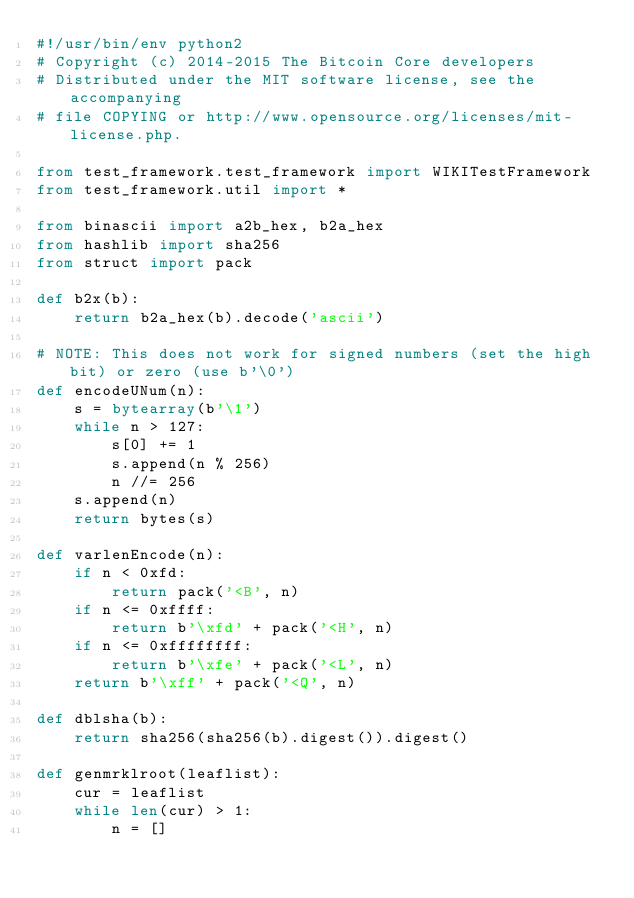<code> <loc_0><loc_0><loc_500><loc_500><_Python_>#!/usr/bin/env python2
# Copyright (c) 2014-2015 The Bitcoin Core developers
# Distributed under the MIT software license, see the accompanying
# file COPYING or http://www.opensource.org/licenses/mit-license.php.

from test_framework.test_framework import WIKITestFramework
from test_framework.util import *

from binascii import a2b_hex, b2a_hex
from hashlib import sha256
from struct import pack

def b2x(b):
    return b2a_hex(b).decode('ascii')

# NOTE: This does not work for signed numbers (set the high bit) or zero (use b'\0')
def encodeUNum(n):
    s = bytearray(b'\1')
    while n > 127:
        s[0] += 1
        s.append(n % 256)
        n //= 256
    s.append(n)
    return bytes(s)

def varlenEncode(n):
    if n < 0xfd:
        return pack('<B', n)
    if n <= 0xffff:
        return b'\xfd' + pack('<H', n)
    if n <= 0xffffffff:
        return b'\xfe' + pack('<L', n)
    return b'\xff' + pack('<Q', n)

def dblsha(b):
    return sha256(sha256(b).digest()).digest()

def genmrklroot(leaflist):
    cur = leaflist
    while len(cur) > 1:
        n = []</code> 